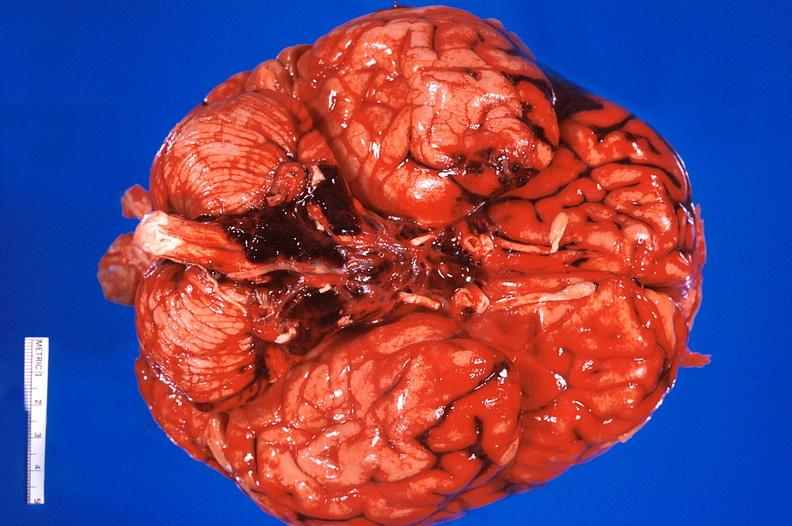s papillary adenoma present?
Answer the question using a single word or phrase. No 